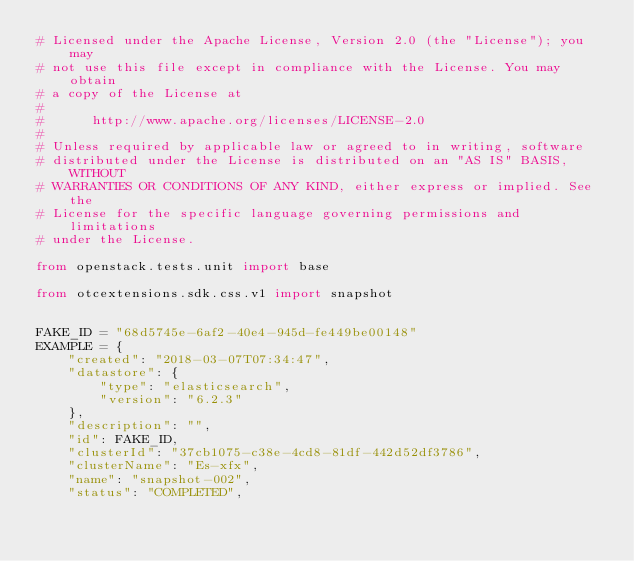Convert code to text. <code><loc_0><loc_0><loc_500><loc_500><_Python_># Licensed under the Apache License, Version 2.0 (the "License"); you may
# not use this file except in compliance with the License. You may obtain
# a copy of the License at
#
#      http://www.apache.org/licenses/LICENSE-2.0
#
# Unless required by applicable law or agreed to in writing, software
# distributed under the License is distributed on an "AS IS" BASIS, WITHOUT
# WARRANTIES OR CONDITIONS OF ANY KIND, either express or implied. See the
# License for the specific language governing permissions and limitations
# under the License.

from openstack.tests.unit import base

from otcextensions.sdk.css.v1 import snapshot


FAKE_ID = "68d5745e-6af2-40e4-945d-fe449be00148"
EXAMPLE = {
    "created": "2018-03-07T07:34:47",
    "datastore": {
        "type": "elasticsearch",
        "version": "6.2.3"
    },
    "description": "",
    "id": FAKE_ID,
    "clusterId": "37cb1075-c38e-4cd8-81df-442d52df3786",
    "clusterName": "Es-xfx",
    "name": "snapshot-002",
    "status": "COMPLETED",</code> 